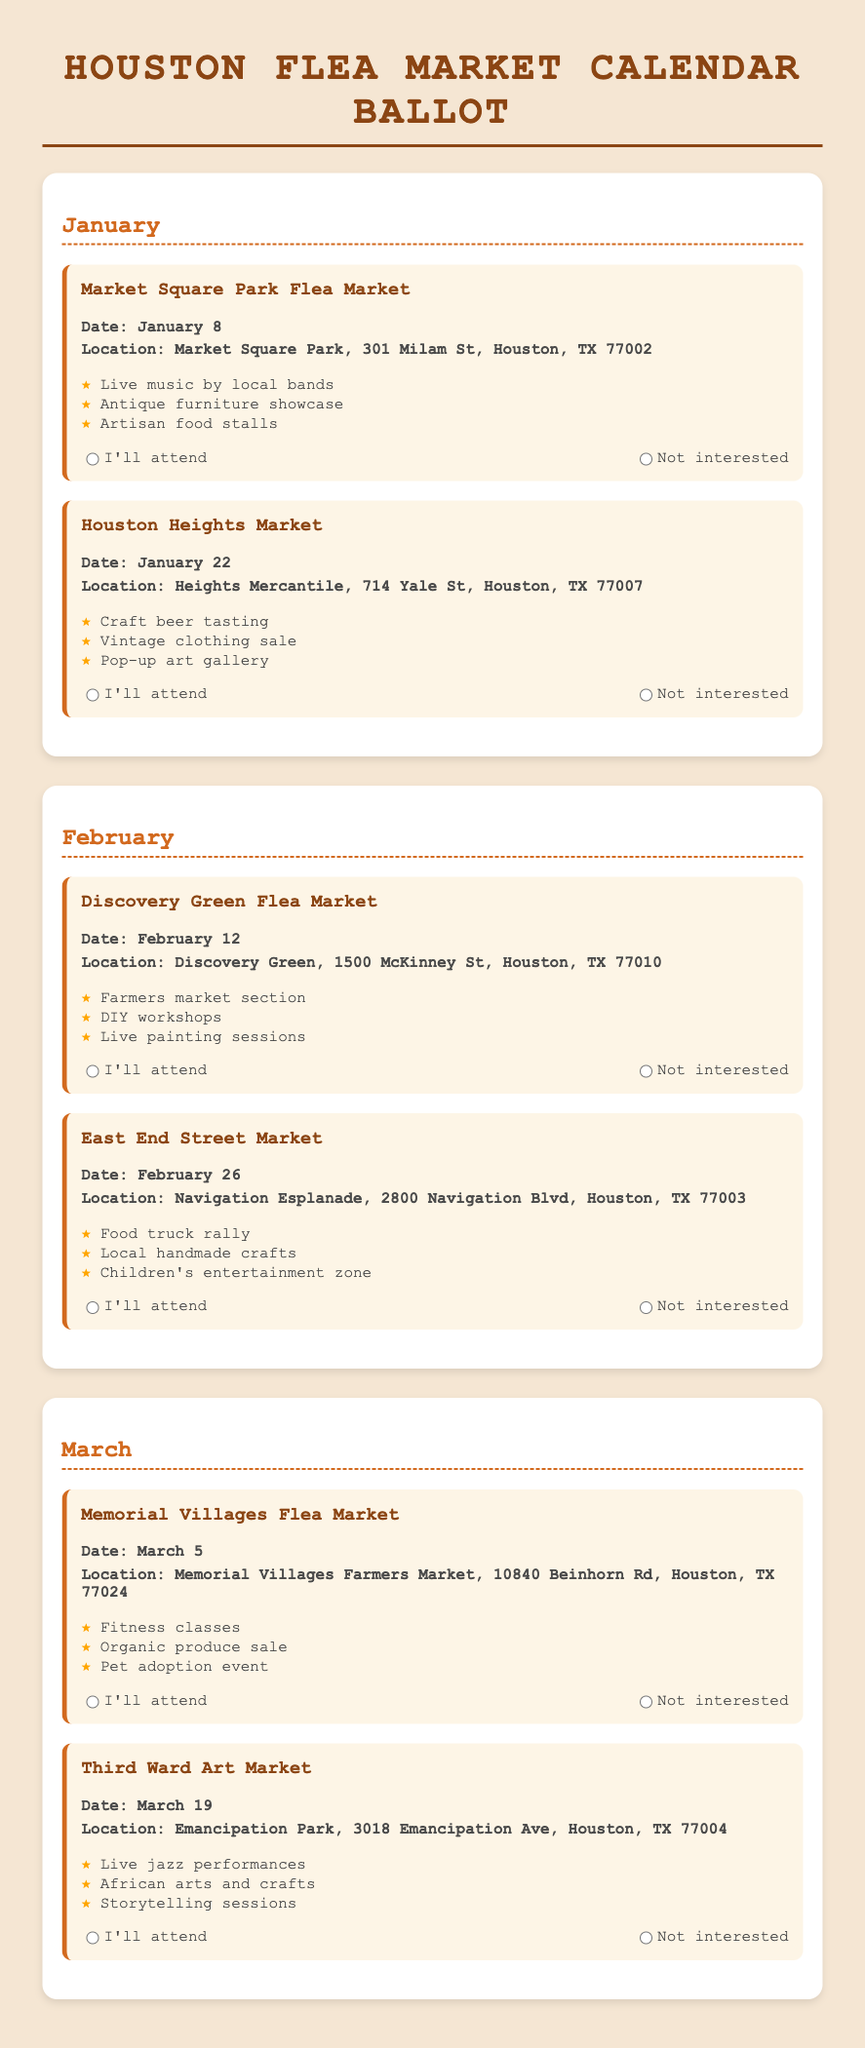What is the date for the Market Square Park Flea Market? The date for the Market Square Park Flea Market is clearly stated in the document.
Answer: January 8 Where is the Houston Heights Market located? The location for the Houston Heights Market is provided in the document.
Answer: Heights Mercantile, 714 Yale St, Houston, TX 77007 What type of entertainment is featured at the Discovery Green Flea Market? The document lists the entertainment options available at the Discovery Green Flea Market.
Answer: DIY workshops How many flea markets are listed for the month of March? The document provides the total number of flea markets featured for March.
Answer: 2 What special attraction is highlighted at the Third Ward Art Market? The document describes special attractions for the Third Ward Art Market.
Answer: Live jazz performances Which flea market takes place on February 26? The specific market date is mentioned in the document for clarification.
Answer: East End Street Market What is the border style used for the month headings? The document describes the visual style elements used for month headings.
Answer: Dashed What action can participants take for each market listed? The document provides options for participant responses regarding attendance at each market.
Answer: Voting 